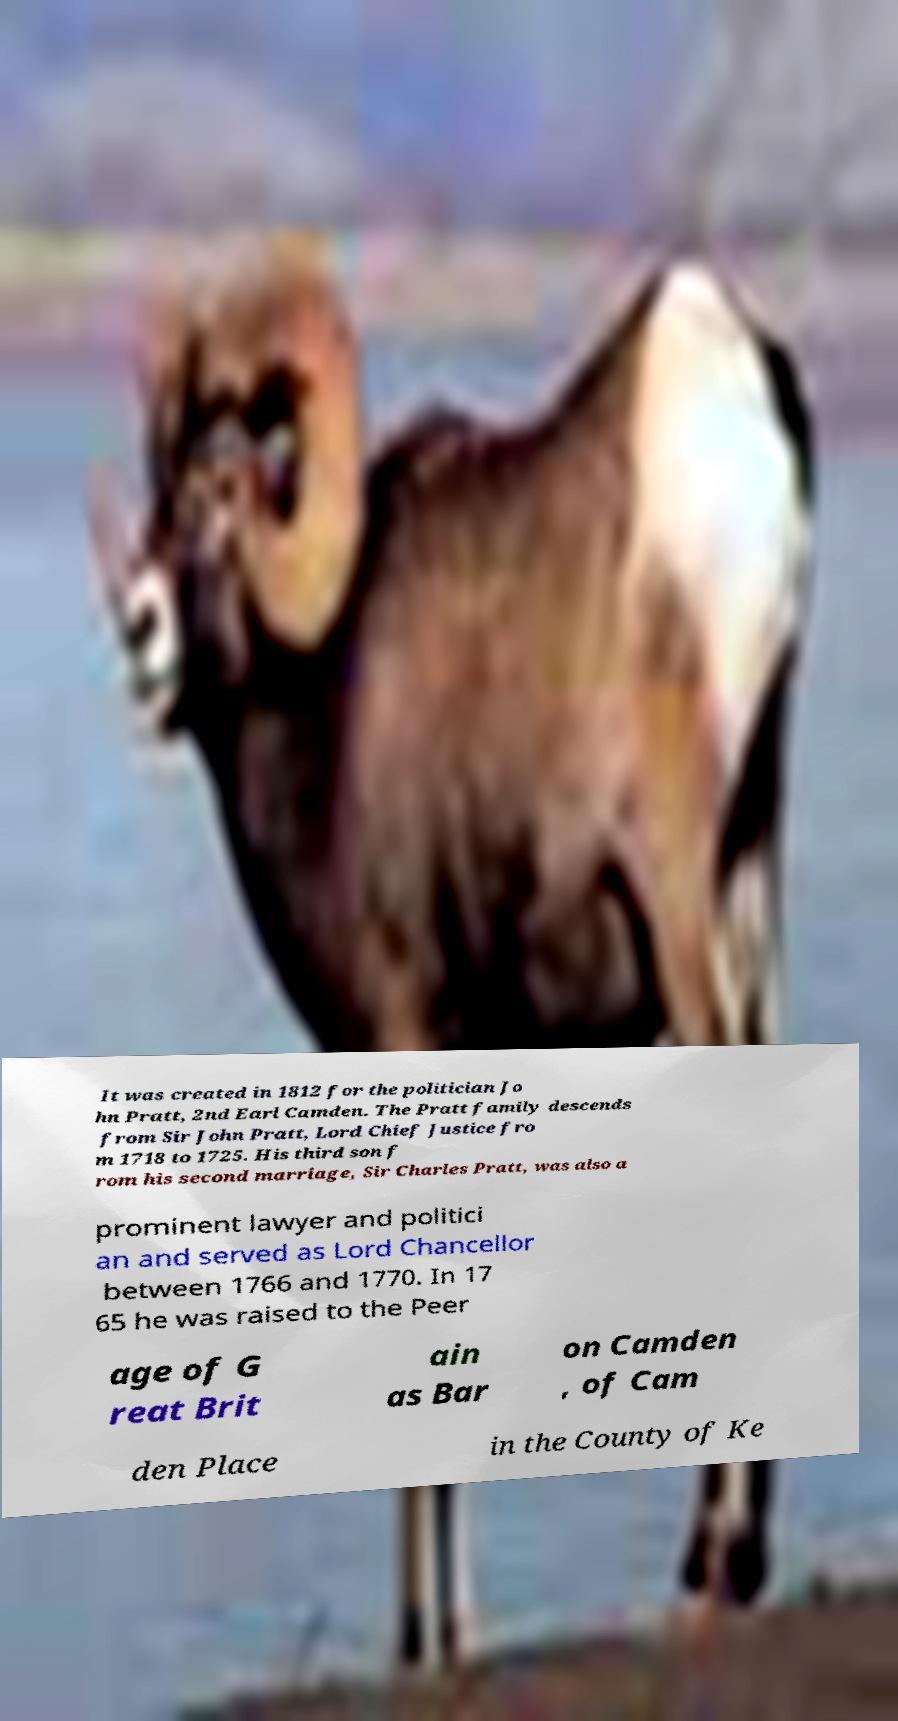Could you extract and type out the text from this image? It was created in 1812 for the politician Jo hn Pratt, 2nd Earl Camden. The Pratt family descends from Sir John Pratt, Lord Chief Justice fro m 1718 to 1725. His third son f rom his second marriage, Sir Charles Pratt, was also a prominent lawyer and politici an and served as Lord Chancellor between 1766 and 1770. In 17 65 he was raised to the Peer age of G reat Brit ain as Bar on Camden , of Cam den Place in the County of Ke 